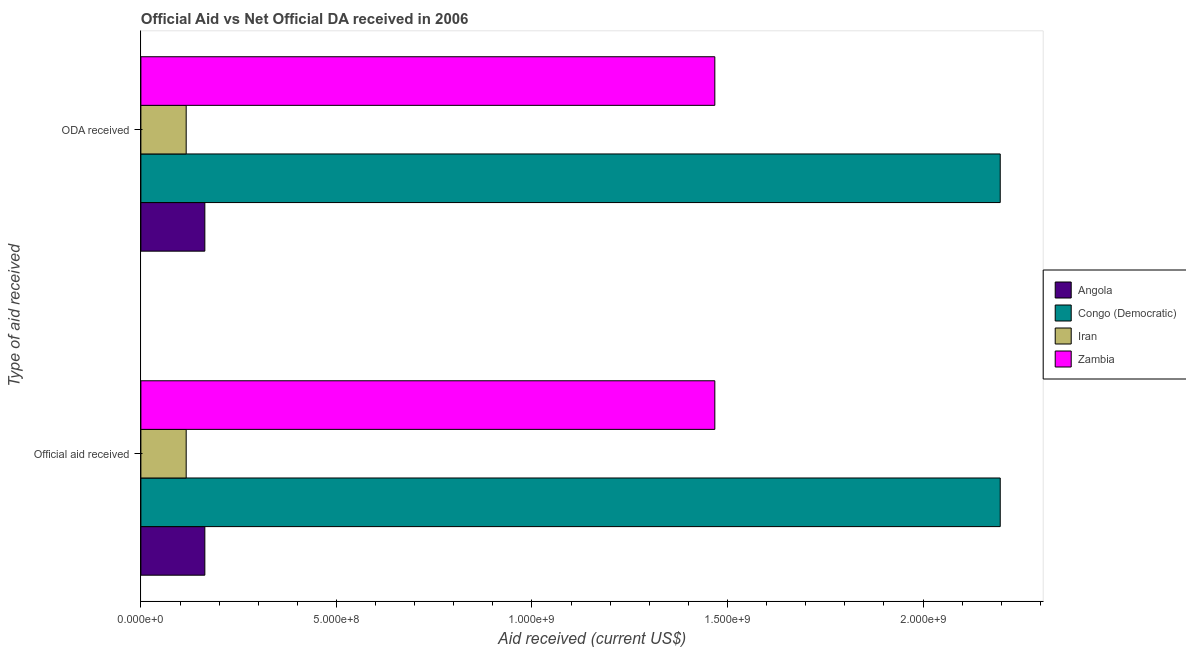How many different coloured bars are there?
Your answer should be very brief. 4. Are the number of bars per tick equal to the number of legend labels?
Make the answer very short. Yes. What is the label of the 2nd group of bars from the top?
Give a very brief answer. Official aid received. What is the official aid received in Zambia?
Make the answer very short. 1.47e+09. Across all countries, what is the maximum oda received?
Keep it short and to the point. 2.20e+09. Across all countries, what is the minimum official aid received?
Give a very brief answer. 1.16e+08. In which country was the oda received maximum?
Provide a succinct answer. Congo (Democratic). In which country was the oda received minimum?
Make the answer very short. Iran. What is the total oda received in the graph?
Your answer should be compact. 3.94e+09. What is the difference between the official aid received in Angola and that in Congo (Democratic)?
Ensure brevity in your answer.  -2.03e+09. What is the difference between the oda received in Zambia and the official aid received in Iran?
Ensure brevity in your answer.  1.35e+09. What is the average oda received per country?
Provide a short and direct response. 9.86e+08. In how many countries, is the official aid received greater than 2000000000 US$?
Keep it short and to the point. 1. What is the ratio of the oda received in Iran to that in Zambia?
Your answer should be compact. 0.08. Is the oda received in Iran less than that in Angola?
Provide a short and direct response. Yes. What does the 3rd bar from the top in ODA received represents?
Offer a very short reply. Congo (Democratic). What does the 2nd bar from the bottom in ODA received represents?
Your response must be concise. Congo (Democratic). Are the values on the major ticks of X-axis written in scientific E-notation?
Give a very brief answer. Yes. Does the graph contain any zero values?
Your response must be concise. No. Does the graph contain grids?
Provide a succinct answer. No. How many legend labels are there?
Your answer should be very brief. 4. How are the legend labels stacked?
Give a very brief answer. Vertical. What is the title of the graph?
Ensure brevity in your answer.  Official Aid vs Net Official DA received in 2006 . What is the label or title of the X-axis?
Give a very brief answer. Aid received (current US$). What is the label or title of the Y-axis?
Offer a very short reply. Type of aid received. What is the Aid received (current US$) of Angola in Official aid received?
Your answer should be compact. 1.64e+08. What is the Aid received (current US$) of Congo (Democratic) in Official aid received?
Offer a very short reply. 2.20e+09. What is the Aid received (current US$) in Iran in Official aid received?
Your answer should be very brief. 1.16e+08. What is the Aid received (current US$) of Zambia in Official aid received?
Ensure brevity in your answer.  1.47e+09. What is the Aid received (current US$) in Angola in ODA received?
Provide a short and direct response. 1.64e+08. What is the Aid received (current US$) in Congo (Democratic) in ODA received?
Keep it short and to the point. 2.20e+09. What is the Aid received (current US$) in Iran in ODA received?
Your answer should be very brief. 1.16e+08. What is the Aid received (current US$) in Zambia in ODA received?
Offer a terse response. 1.47e+09. Across all Type of aid received, what is the maximum Aid received (current US$) of Angola?
Provide a succinct answer. 1.64e+08. Across all Type of aid received, what is the maximum Aid received (current US$) in Congo (Democratic)?
Provide a short and direct response. 2.20e+09. Across all Type of aid received, what is the maximum Aid received (current US$) of Iran?
Offer a very short reply. 1.16e+08. Across all Type of aid received, what is the maximum Aid received (current US$) of Zambia?
Offer a very short reply. 1.47e+09. Across all Type of aid received, what is the minimum Aid received (current US$) of Angola?
Keep it short and to the point. 1.64e+08. Across all Type of aid received, what is the minimum Aid received (current US$) in Congo (Democratic)?
Keep it short and to the point. 2.20e+09. Across all Type of aid received, what is the minimum Aid received (current US$) of Iran?
Offer a terse response. 1.16e+08. Across all Type of aid received, what is the minimum Aid received (current US$) of Zambia?
Your answer should be very brief. 1.47e+09. What is the total Aid received (current US$) in Angola in the graph?
Provide a succinct answer. 3.27e+08. What is the total Aid received (current US$) of Congo (Democratic) in the graph?
Keep it short and to the point. 4.39e+09. What is the total Aid received (current US$) in Iran in the graph?
Provide a succinct answer. 2.32e+08. What is the total Aid received (current US$) in Zambia in the graph?
Provide a succinct answer. 2.94e+09. What is the difference between the Aid received (current US$) in Angola in Official aid received and that in ODA received?
Offer a very short reply. 0. What is the difference between the Aid received (current US$) in Zambia in Official aid received and that in ODA received?
Give a very brief answer. 0. What is the difference between the Aid received (current US$) of Angola in Official aid received and the Aid received (current US$) of Congo (Democratic) in ODA received?
Provide a succinct answer. -2.03e+09. What is the difference between the Aid received (current US$) of Angola in Official aid received and the Aid received (current US$) of Iran in ODA received?
Keep it short and to the point. 4.77e+07. What is the difference between the Aid received (current US$) of Angola in Official aid received and the Aid received (current US$) of Zambia in ODA received?
Make the answer very short. -1.30e+09. What is the difference between the Aid received (current US$) in Congo (Democratic) in Official aid received and the Aid received (current US$) in Iran in ODA received?
Offer a terse response. 2.08e+09. What is the difference between the Aid received (current US$) of Congo (Democratic) in Official aid received and the Aid received (current US$) of Zambia in ODA received?
Ensure brevity in your answer.  7.30e+08. What is the difference between the Aid received (current US$) of Iran in Official aid received and the Aid received (current US$) of Zambia in ODA received?
Offer a terse response. -1.35e+09. What is the average Aid received (current US$) of Angola per Type of aid received?
Provide a succinct answer. 1.64e+08. What is the average Aid received (current US$) of Congo (Democratic) per Type of aid received?
Make the answer very short. 2.20e+09. What is the average Aid received (current US$) of Iran per Type of aid received?
Offer a very short reply. 1.16e+08. What is the average Aid received (current US$) in Zambia per Type of aid received?
Your answer should be compact. 1.47e+09. What is the difference between the Aid received (current US$) of Angola and Aid received (current US$) of Congo (Democratic) in Official aid received?
Provide a succinct answer. -2.03e+09. What is the difference between the Aid received (current US$) of Angola and Aid received (current US$) of Iran in Official aid received?
Your answer should be very brief. 4.77e+07. What is the difference between the Aid received (current US$) of Angola and Aid received (current US$) of Zambia in Official aid received?
Make the answer very short. -1.30e+09. What is the difference between the Aid received (current US$) in Congo (Democratic) and Aid received (current US$) in Iran in Official aid received?
Your answer should be very brief. 2.08e+09. What is the difference between the Aid received (current US$) in Congo (Democratic) and Aid received (current US$) in Zambia in Official aid received?
Offer a very short reply. 7.30e+08. What is the difference between the Aid received (current US$) of Iran and Aid received (current US$) of Zambia in Official aid received?
Offer a terse response. -1.35e+09. What is the difference between the Aid received (current US$) in Angola and Aid received (current US$) in Congo (Democratic) in ODA received?
Your response must be concise. -2.03e+09. What is the difference between the Aid received (current US$) in Angola and Aid received (current US$) in Iran in ODA received?
Keep it short and to the point. 4.77e+07. What is the difference between the Aid received (current US$) of Angola and Aid received (current US$) of Zambia in ODA received?
Make the answer very short. -1.30e+09. What is the difference between the Aid received (current US$) in Congo (Democratic) and Aid received (current US$) in Iran in ODA received?
Your response must be concise. 2.08e+09. What is the difference between the Aid received (current US$) in Congo (Democratic) and Aid received (current US$) in Zambia in ODA received?
Ensure brevity in your answer.  7.30e+08. What is the difference between the Aid received (current US$) in Iran and Aid received (current US$) in Zambia in ODA received?
Provide a succinct answer. -1.35e+09. What is the ratio of the Aid received (current US$) in Iran in Official aid received to that in ODA received?
Your answer should be compact. 1. What is the difference between the highest and the lowest Aid received (current US$) in Angola?
Give a very brief answer. 0. What is the difference between the highest and the lowest Aid received (current US$) in Congo (Democratic)?
Your response must be concise. 0. What is the difference between the highest and the lowest Aid received (current US$) of Iran?
Ensure brevity in your answer.  0. What is the difference between the highest and the lowest Aid received (current US$) in Zambia?
Make the answer very short. 0. 